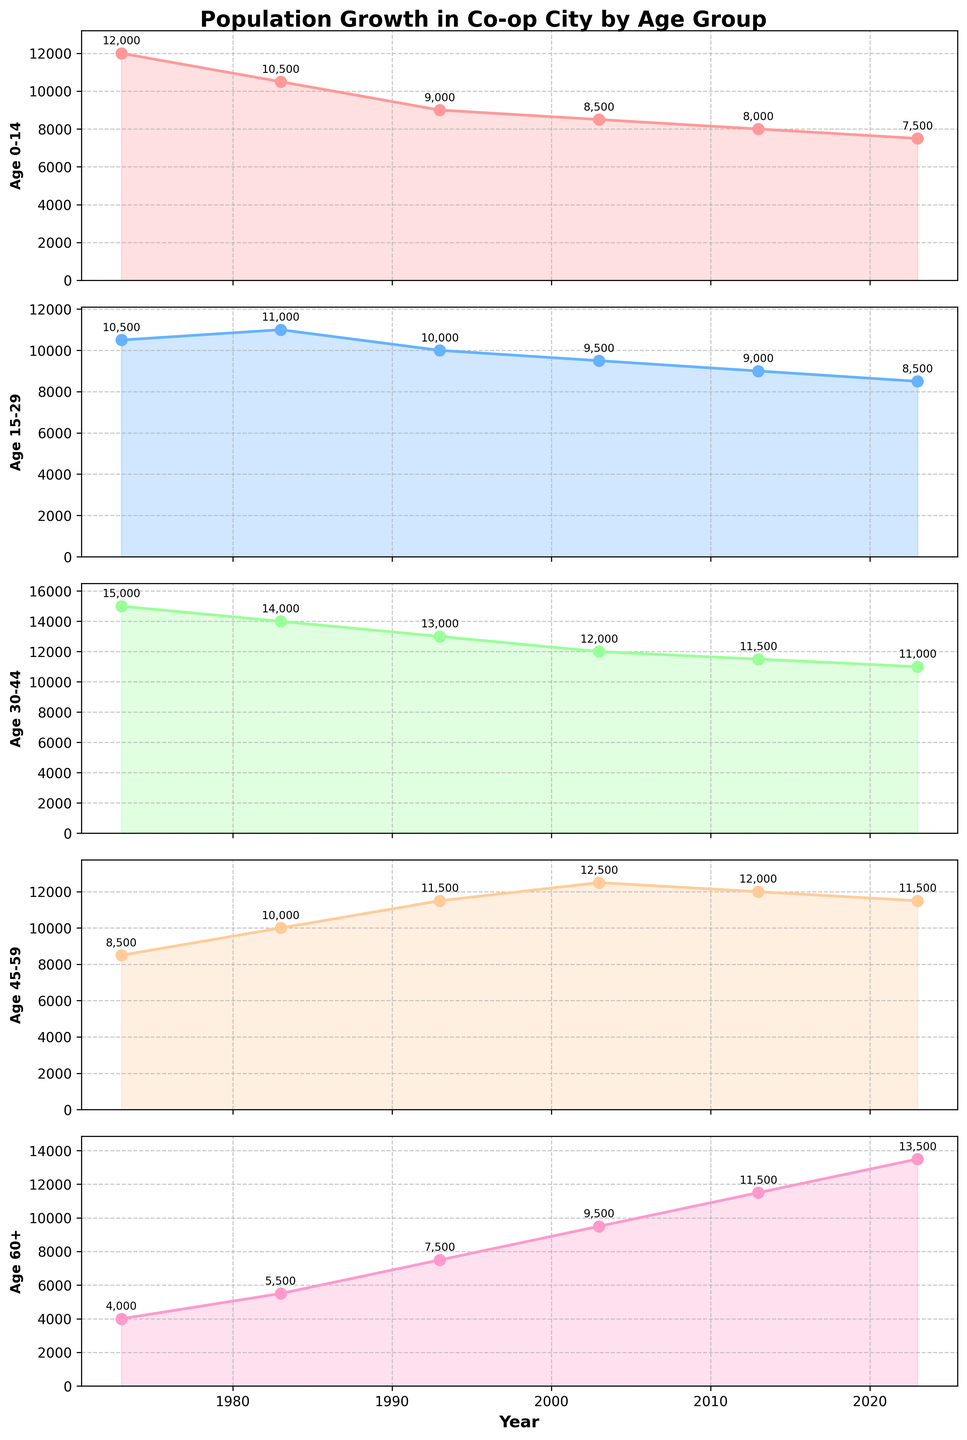What is the title of the figure? The title of the figure is shown at the top and reads "Population Growth in Co-op City by Age Group."
Answer: Population Growth in Co-op City by Age Group What are the five age groups shown in the figure? The five age groups are labeled on the y-axis of each subplot from top to bottom as "0-14", "15-29", "30-44", "45-59", and "60+."
Answer: 0-14, 15-29, 30-44, 45-59, 60+ What age group had the highest population in 2023? To find the age group with the highest population in 2023, we look at the data points in the columns for the year 2023. The "60+" age group has the highest value at 13,500.
Answer: 60+ Which age group experienced a continuous decline in population from 1973 to 2023? By examining the plots of each age group over the years from 1973 to 2023, only the "0-14" age group shows a continuous decline.
Answer: 0-14 What is the total population of the "30-44" age group over the entire period? The total population over all years for the "30-44" age group is the sum of all its data points: 15,000 + 14,000 + 13,000 + 12,000 + 11,500 + 11,000 = 76,500.
Answer: 76,500 In which decade did the "45-59" age group see the largest increase in population? Comparing the population differences between each successive decade for the "45-59" age group: (1983-1973)=1,500, (1993-1983)=1,500, (2003-1993)=1,000, (2013-2003)=-500, (2023-2013)=-500, the largest increase is between 1993 and 1983.
Answer: 1983-1993 Which age group had the smallest population in 1973? The smallest population in 1973 can be identified by comparing data points for that year, where the "60+" age group has the lowest value at 4,000.
Answer: 60+ What was the average population of the "15-29" age group across the six decades shown? Summing the populations for the "15-29" age group then dividing by the number of years: (10,500 + 11,000 + 10,000 + 9,500 + 9,000 + 8,500) / 6 = 9,750.
Answer: 9,750 